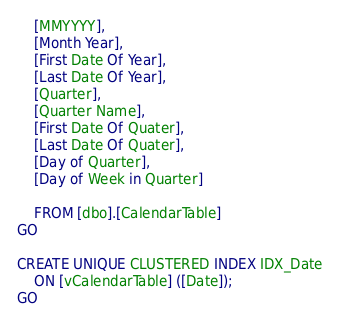<code> <loc_0><loc_0><loc_500><loc_500><_SQL_>	[MMYYYY],
	[Month Year],
	[First Date Of Year],
	[Last Date Of Year],
	[Quarter],
	[Quarter Name],
	[First Date Of Quater],
	[Last Date Of Quater],
	[Day of Quarter],
	[Day of Week in Quarter]

	FROM [dbo].[CalendarTable]
GO

CREATE UNIQUE CLUSTERED INDEX IDX_Date
	ON [vCalendarTable] ([Date]);
GO</code> 